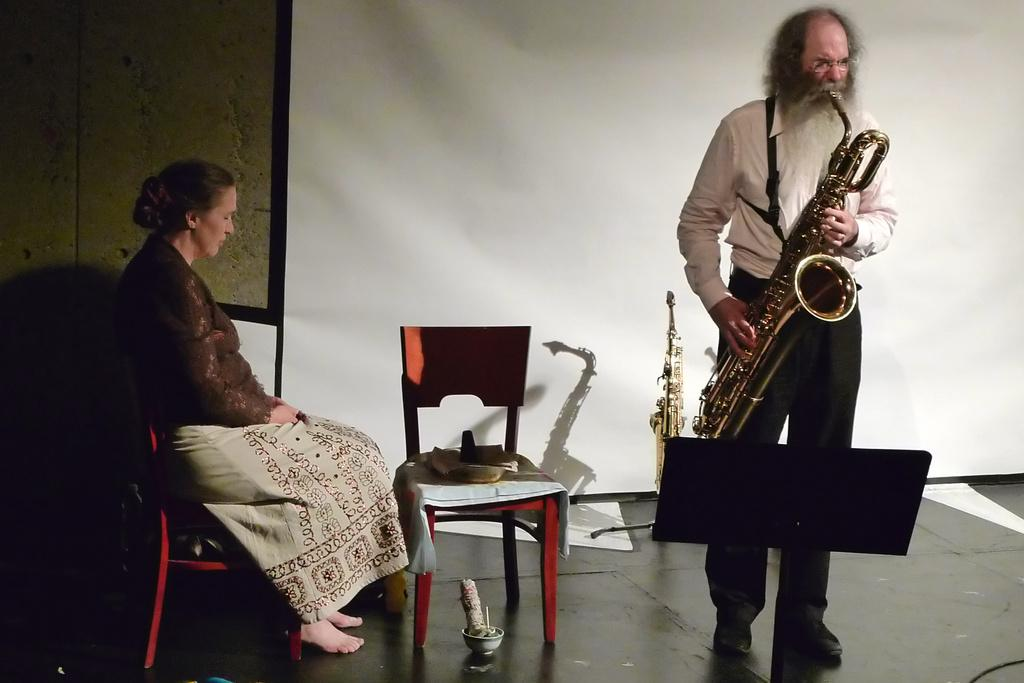How many people are in the image? There are two persons in the image. What is one person doing in the image? One person is playing a trumpet. What is the other person's position in the image? The other person is sitting on a chair. What can be seen in the background of the image? There is a wall in the background of the image. What type of station can be seen in the image? There is no station present in the image. What kind of harmony is being played by the person with the trumpet? The image does not provide information about the type of harmony being played, as it only shows a person playing a trumpet. 